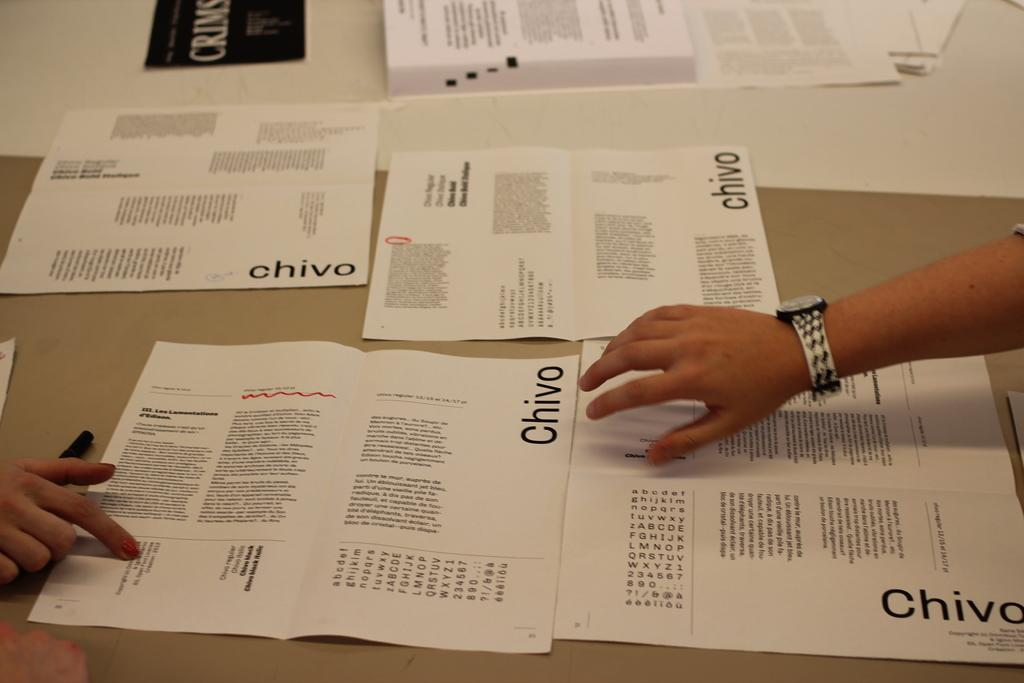What objects are on the table in the image? There are papers on a table in the image. Can you describe any body parts visible in the image? Yes, there are persons' hands visible in the image. What type of feather can be seen in the image? There is no feather present in the image. How does the friction between the hands and the papers affect the image? The image does not provide information about the friction between the hands and the papers, so we cannot determine its effect on the image. 